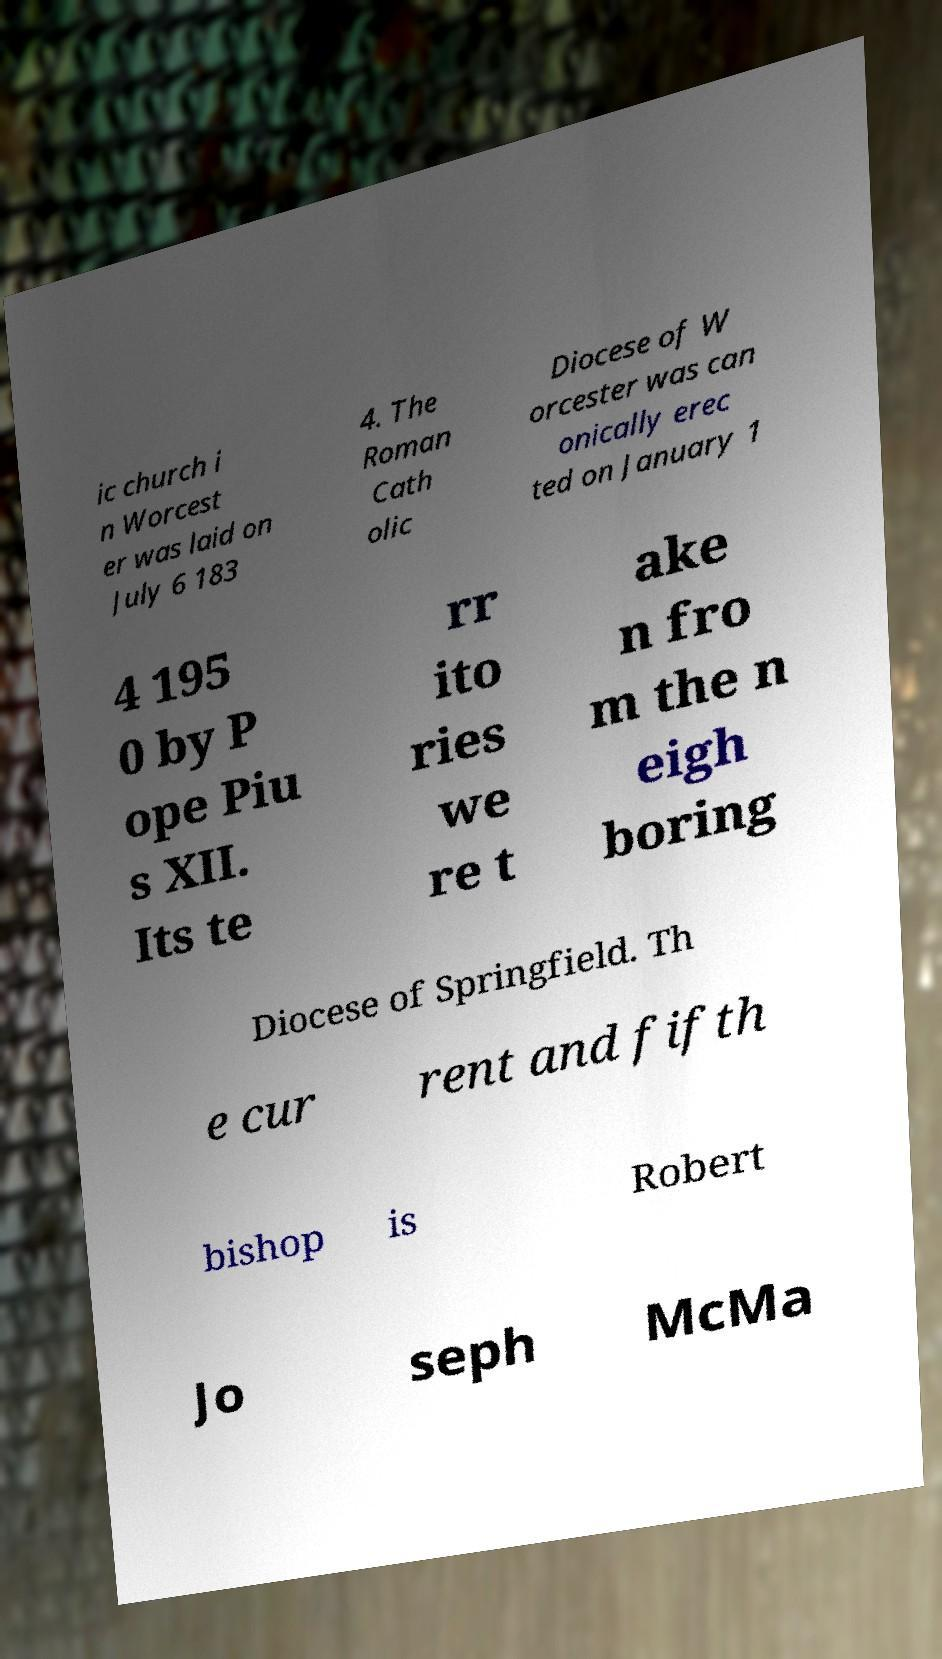Can you accurately transcribe the text from the provided image for me? ic church i n Worcest er was laid on July 6 183 4. The Roman Cath olic Diocese of W orcester was can onically erec ted on January 1 4 195 0 by P ope Piu s XII. Its te rr ito ries we re t ake n fro m the n eigh boring Diocese of Springfield. Th e cur rent and fifth bishop is Robert Jo seph McMa 